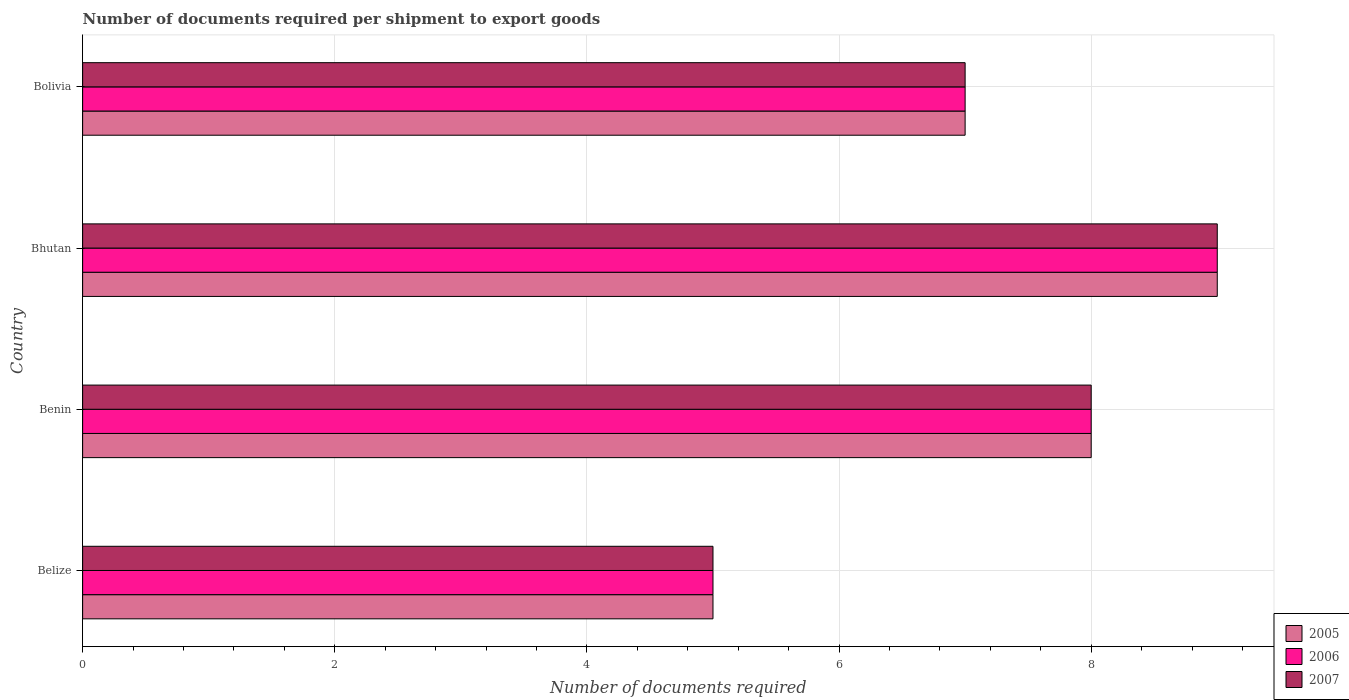How many different coloured bars are there?
Offer a terse response. 3. How many groups of bars are there?
Provide a short and direct response. 4. What is the label of the 4th group of bars from the top?
Offer a terse response. Belize. In how many cases, is the number of bars for a given country not equal to the number of legend labels?
Offer a very short reply. 0. Across all countries, what is the maximum number of documents required per shipment to export goods in 2006?
Give a very brief answer. 9. Across all countries, what is the minimum number of documents required per shipment to export goods in 2006?
Keep it short and to the point. 5. In which country was the number of documents required per shipment to export goods in 2005 maximum?
Provide a succinct answer. Bhutan. In which country was the number of documents required per shipment to export goods in 2006 minimum?
Your response must be concise. Belize. What is the total number of documents required per shipment to export goods in 2007 in the graph?
Your answer should be very brief. 29. What is the difference between the number of documents required per shipment to export goods in 2006 in Belize and that in Bolivia?
Offer a terse response. -2. What is the difference between the number of documents required per shipment to export goods in 2006 in Belize and the number of documents required per shipment to export goods in 2007 in Benin?
Give a very brief answer. -3. What is the average number of documents required per shipment to export goods in 2007 per country?
Offer a terse response. 7.25. In how many countries, is the number of documents required per shipment to export goods in 2006 greater than 1.6 ?
Your answer should be compact. 4. What is the ratio of the number of documents required per shipment to export goods in 2006 in Bhutan to that in Bolivia?
Your response must be concise. 1.29. In how many countries, is the number of documents required per shipment to export goods in 2006 greater than the average number of documents required per shipment to export goods in 2006 taken over all countries?
Offer a very short reply. 2. Is the sum of the number of documents required per shipment to export goods in 2007 in Belize and Bhutan greater than the maximum number of documents required per shipment to export goods in 2006 across all countries?
Your answer should be very brief. Yes. What does the 1st bar from the bottom in Bhutan represents?
Ensure brevity in your answer.  2005. Is it the case that in every country, the sum of the number of documents required per shipment to export goods in 2006 and number of documents required per shipment to export goods in 2005 is greater than the number of documents required per shipment to export goods in 2007?
Provide a succinct answer. Yes. How many bars are there?
Give a very brief answer. 12. Are the values on the major ticks of X-axis written in scientific E-notation?
Offer a terse response. No. Does the graph contain any zero values?
Your answer should be very brief. No. Does the graph contain grids?
Provide a short and direct response. Yes. Where does the legend appear in the graph?
Ensure brevity in your answer.  Bottom right. What is the title of the graph?
Your response must be concise. Number of documents required per shipment to export goods. What is the label or title of the X-axis?
Give a very brief answer. Number of documents required. What is the label or title of the Y-axis?
Provide a short and direct response. Country. What is the Number of documents required of 2005 in Belize?
Make the answer very short. 5. What is the Number of documents required in 2006 in Belize?
Offer a terse response. 5. What is the Number of documents required of 2007 in Benin?
Offer a very short reply. 8. What is the Number of documents required of 2005 in Bhutan?
Offer a very short reply. 9. What is the Number of documents required of 2006 in Bhutan?
Offer a very short reply. 9. What is the Number of documents required of 2006 in Bolivia?
Your answer should be very brief. 7. What is the Number of documents required of 2007 in Bolivia?
Your answer should be compact. 7. Across all countries, what is the maximum Number of documents required in 2005?
Provide a short and direct response. 9. Across all countries, what is the maximum Number of documents required in 2006?
Make the answer very short. 9. Across all countries, what is the maximum Number of documents required of 2007?
Offer a very short reply. 9. Across all countries, what is the minimum Number of documents required in 2005?
Provide a short and direct response. 5. Across all countries, what is the minimum Number of documents required in 2007?
Make the answer very short. 5. What is the total Number of documents required in 2005 in the graph?
Offer a terse response. 29. What is the total Number of documents required of 2007 in the graph?
Your response must be concise. 29. What is the difference between the Number of documents required of 2005 in Belize and that in Benin?
Your answer should be very brief. -3. What is the difference between the Number of documents required of 2006 in Belize and that in Benin?
Your answer should be compact. -3. What is the difference between the Number of documents required in 2007 in Belize and that in Benin?
Provide a short and direct response. -3. What is the difference between the Number of documents required in 2005 in Belize and that in Bhutan?
Provide a succinct answer. -4. What is the difference between the Number of documents required in 2006 in Belize and that in Bhutan?
Provide a succinct answer. -4. What is the difference between the Number of documents required in 2005 in Belize and that in Bolivia?
Your response must be concise. -2. What is the difference between the Number of documents required in 2006 in Belize and that in Bolivia?
Provide a succinct answer. -2. What is the difference between the Number of documents required of 2007 in Belize and that in Bolivia?
Keep it short and to the point. -2. What is the difference between the Number of documents required of 2005 in Benin and that in Bhutan?
Make the answer very short. -1. What is the difference between the Number of documents required of 2006 in Benin and that in Bhutan?
Offer a very short reply. -1. What is the difference between the Number of documents required in 2005 in Benin and that in Bolivia?
Ensure brevity in your answer.  1. What is the difference between the Number of documents required of 2006 in Benin and that in Bolivia?
Make the answer very short. 1. What is the difference between the Number of documents required of 2007 in Benin and that in Bolivia?
Keep it short and to the point. 1. What is the difference between the Number of documents required of 2005 in Bhutan and that in Bolivia?
Ensure brevity in your answer.  2. What is the difference between the Number of documents required in 2006 in Bhutan and that in Bolivia?
Your answer should be very brief. 2. What is the difference between the Number of documents required of 2007 in Bhutan and that in Bolivia?
Keep it short and to the point. 2. What is the difference between the Number of documents required of 2005 in Belize and the Number of documents required of 2006 in Benin?
Keep it short and to the point. -3. What is the difference between the Number of documents required in 2005 in Belize and the Number of documents required in 2007 in Bhutan?
Keep it short and to the point. -4. What is the difference between the Number of documents required of 2005 in Belize and the Number of documents required of 2007 in Bolivia?
Keep it short and to the point. -2. What is the difference between the Number of documents required of 2006 in Belize and the Number of documents required of 2007 in Bolivia?
Keep it short and to the point. -2. What is the difference between the Number of documents required in 2005 in Benin and the Number of documents required in 2007 in Bhutan?
Provide a succinct answer. -1. What is the difference between the Number of documents required of 2005 in Benin and the Number of documents required of 2006 in Bolivia?
Provide a short and direct response. 1. What is the difference between the Number of documents required in 2005 in Benin and the Number of documents required in 2007 in Bolivia?
Provide a short and direct response. 1. What is the difference between the Number of documents required in 2006 in Benin and the Number of documents required in 2007 in Bolivia?
Provide a succinct answer. 1. What is the difference between the Number of documents required in 2005 in Bhutan and the Number of documents required in 2006 in Bolivia?
Give a very brief answer. 2. What is the difference between the Number of documents required in 2005 in Bhutan and the Number of documents required in 2007 in Bolivia?
Ensure brevity in your answer.  2. What is the average Number of documents required of 2005 per country?
Make the answer very short. 7.25. What is the average Number of documents required in 2006 per country?
Keep it short and to the point. 7.25. What is the average Number of documents required in 2007 per country?
Offer a very short reply. 7.25. What is the difference between the Number of documents required of 2005 and Number of documents required of 2006 in Benin?
Provide a succinct answer. 0. What is the difference between the Number of documents required of 2005 and Number of documents required of 2007 in Benin?
Offer a terse response. 0. What is the difference between the Number of documents required of 2006 and Number of documents required of 2007 in Benin?
Provide a succinct answer. 0. What is the difference between the Number of documents required of 2005 and Number of documents required of 2007 in Bhutan?
Make the answer very short. 0. What is the difference between the Number of documents required in 2005 and Number of documents required in 2006 in Bolivia?
Provide a succinct answer. 0. What is the difference between the Number of documents required of 2006 and Number of documents required of 2007 in Bolivia?
Offer a terse response. 0. What is the ratio of the Number of documents required of 2005 in Belize to that in Benin?
Offer a terse response. 0.62. What is the ratio of the Number of documents required in 2007 in Belize to that in Benin?
Make the answer very short. 0.62. What is the ratio of the Number of documents required of 2005 in Belize to that in Bhutan?
Your answer should be very brief. 0.56. What is the ratio of the Number of documents required in 2006 in Belize to that in Bhutan?
Offer a very short reply. 0.56. What is the ratio of the Number of documents required of 2007 in Belize to that in Bhutan?
Your response must be concise. 0.56. What is the ratio of the Number of documents required of 2005 in Benin to that in Bhutan?
Your response must be concise. 0.89. What is the ratio of the Number of documents required in 2005 in Benin to that in Bolivia?
Your response must be concise. 1.14. What is the ratio of the Number of documents required of 2007 in Benin to that in Bolivia?
Ensure brevity in your answer.  1.14. What is the ratio of the Number of documents required of 2005 in Bhutan to that in Bolivia?
Provide a succinct answer. 1.29. What is the ratio of the Number of documents required of 2007 in Bhutan to that in Bolivia?
Make the answer very short. 1.29. What is the difference between the highest and the second highest Number of documents required of 2005?
Offer a terse response. 1. What is the difference between the highest and the second highest Number of documents required in 2006?
Provide a succinct answer. 1. What is the difference between the highest and the lowest Number of documents required of 2005?
Your answer should be very brief. 4. What is the difference between the highest and the lowest Number of documents required in 2006?
Ensure brevity in your answer.  4. What is the difference between the highest and the lowest Number of documents required in 2007?
Give a very brief answer. 4. 